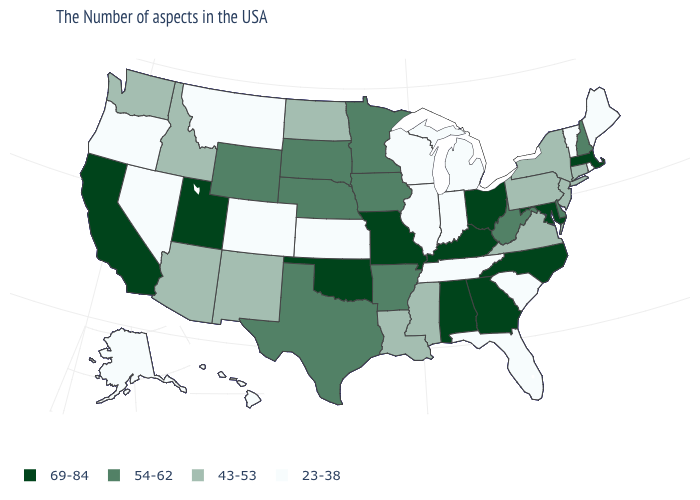Which states have the lowest value in the USA?
Be succinct. Maine, Rhode Island, Vermont, South Carolina, Florida, Michigan, Indiana, Tennessee, Wisconsin, Illinois, Kansas, Colorado, Montana, Nevada, Oregon, Alaska, Hawaii. Does Kansas have the lowest value in the MidWest?
Answer briefly. Yes. What is the value of Washington?
Give a very brief answer. 43-53. What is the value of North Dakota?
Concise answer only. 43-53. How many symbols are there in the legend?
Keep it brief. 4. What is the highest value in the MidWest ?
Quick response, please. 69-84. What is the value of New Hampshire?
Short answer required. 54-62. What is the value of Alabama?
Quick response, please. 69-84. What is the lowest value in the USA?
Quick response, please. 23-38. Name the states that have a value in the range 23-38?
Give a very brief answer. Maine, Rhode Island, Vermont, South Carolina, Florida, Michigan, Indiana, Tennessee, Wisconsin, Illinois, Kansas, Colorado, Montana, Nevada, Oregon, Alaska, Hawaii. Which states have the lowest value in the USA?
Be succinct. Maine, Rhode Island, Vermont, South Carolina, Florida, Michigan, Indiana, Tennessee, Wisconsin, Illinois, Kansas, Colorado, Montana, Nevada, Oregon, Alaska, Hawaii. What is the lowest value in states that border Connecticut?
Quick response, please. 23-38. What is the value of Montana?
Give a very brief answer. 23-38. Does Maine have the highest value in the USA?
Be succinct. No. 